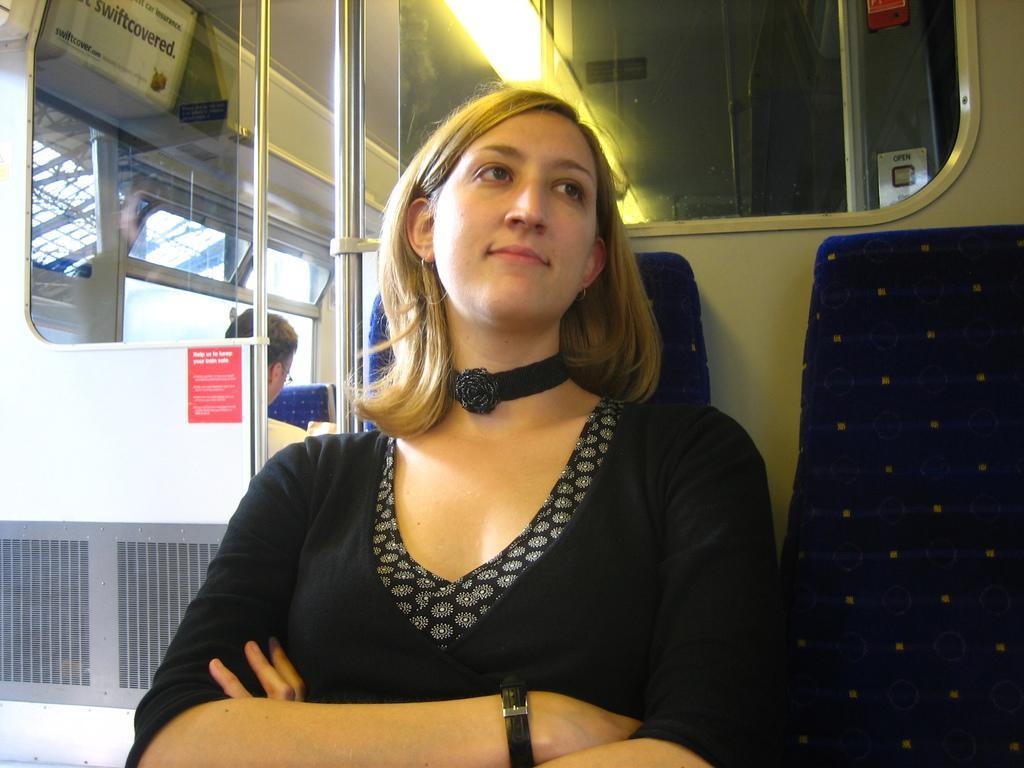In one or two sentences, can you explain what this image depicts? In this image I see the inside view of the public transport and I see a woman who is sitting and she is wearing black dress and I see the lights in the background and I can also see the poles and I see another chair over here and I see few words written over here and I see a person sitting over here. 